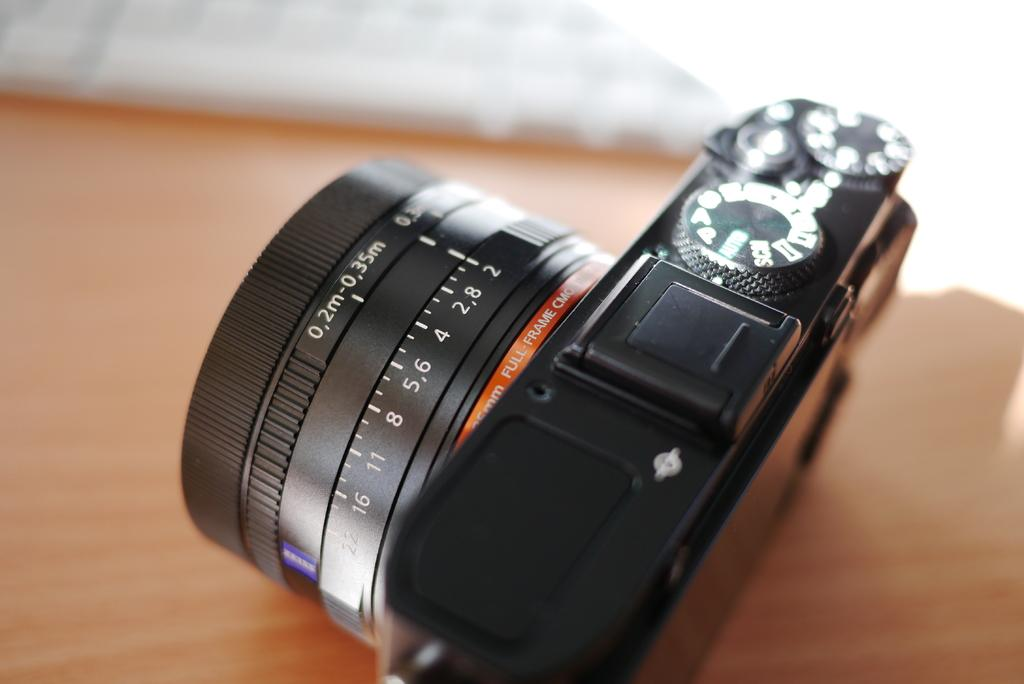<image>
Relay a brief, clear account of the picture shown. a side view of an unnamed camer with some numbers printed on it and 35 mm Full Frame 